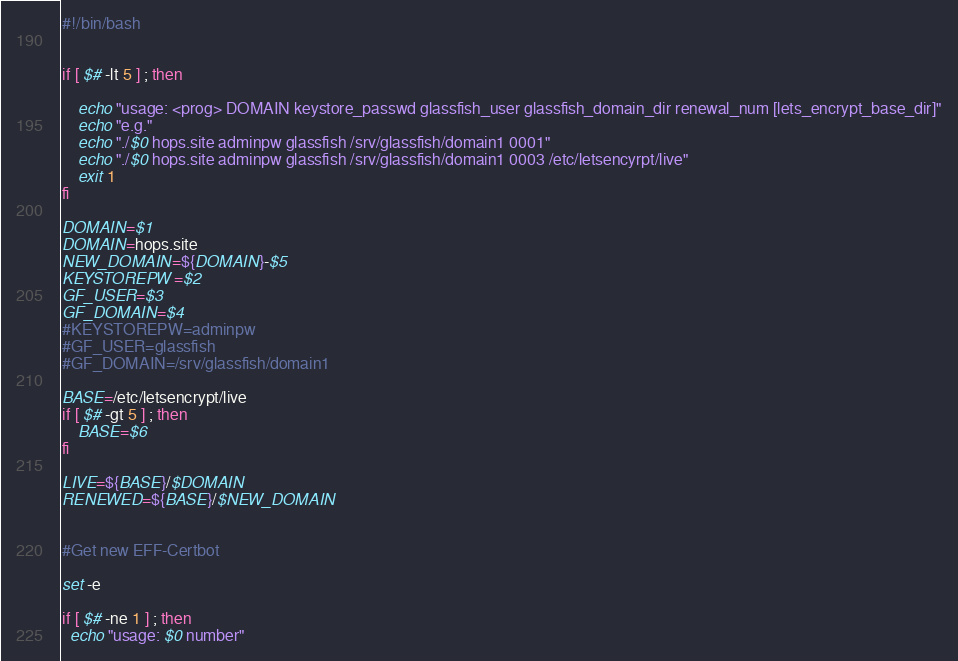<code> <loc_0><loc_0><loc_500><loc_500><_Bash_>#!/bin/bash


if [ $# -lt 5 ] ; then

    echo "usage: <prog> DOMAIN keystore_passwd glassfish_user glassfish_domain_dir renewal_num [lets_encrypt_base_dir]"
    echo "e.g."
    echo "./$0 hops.site adminpw glassfish /srv/glassfish/domain1 0001"
    echo "./$0 hops.site adminpw glassfish /srv/glassfish/domain1 0003 /etc/letsencyrpt/live"    
    exit 1
fi

DOMAIN=$1
DOMAIN=hops.site
NEW_DOMAIN=${DOMAIN}-$5
KEYSTOREPW=$2
GF_USER=$3
GF_DOMAIN=$4
#KEYSTOREPW=adminpw
#GF_USER=glassfish
#GF_DOMAIN=/srv/glassfish/domain1

BASE=/etc/letsencrypt/live 
if [ $# -gt 5 ] ; then
    BASE=$6
fi    

LIVE=${BASE}/$DOMAIN
RENEWED=${BASE}/$NEW_DOMAIN


#Get new EFF-Certbot

set -e

if [ $# -ne 1 ] ; then
  echo "usage: $0 number"</code> 